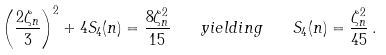<formula> <loc_0><loc_0><loc_500><loc_500>\left ( \frac { 2 \zeta _ { n } } { 3 } \right ) ^ { 2 } + 4 S _ { 4 } ( n ) = \frac { 8 \zeta _ { n } ^ { 2 } } { 1 5 } \quad y i e l d i n g \quad S _ { 4 } ( n ) = \frac { \zeta _ { n } ^ { 2 } } { 4 5 } \, .</formula> 